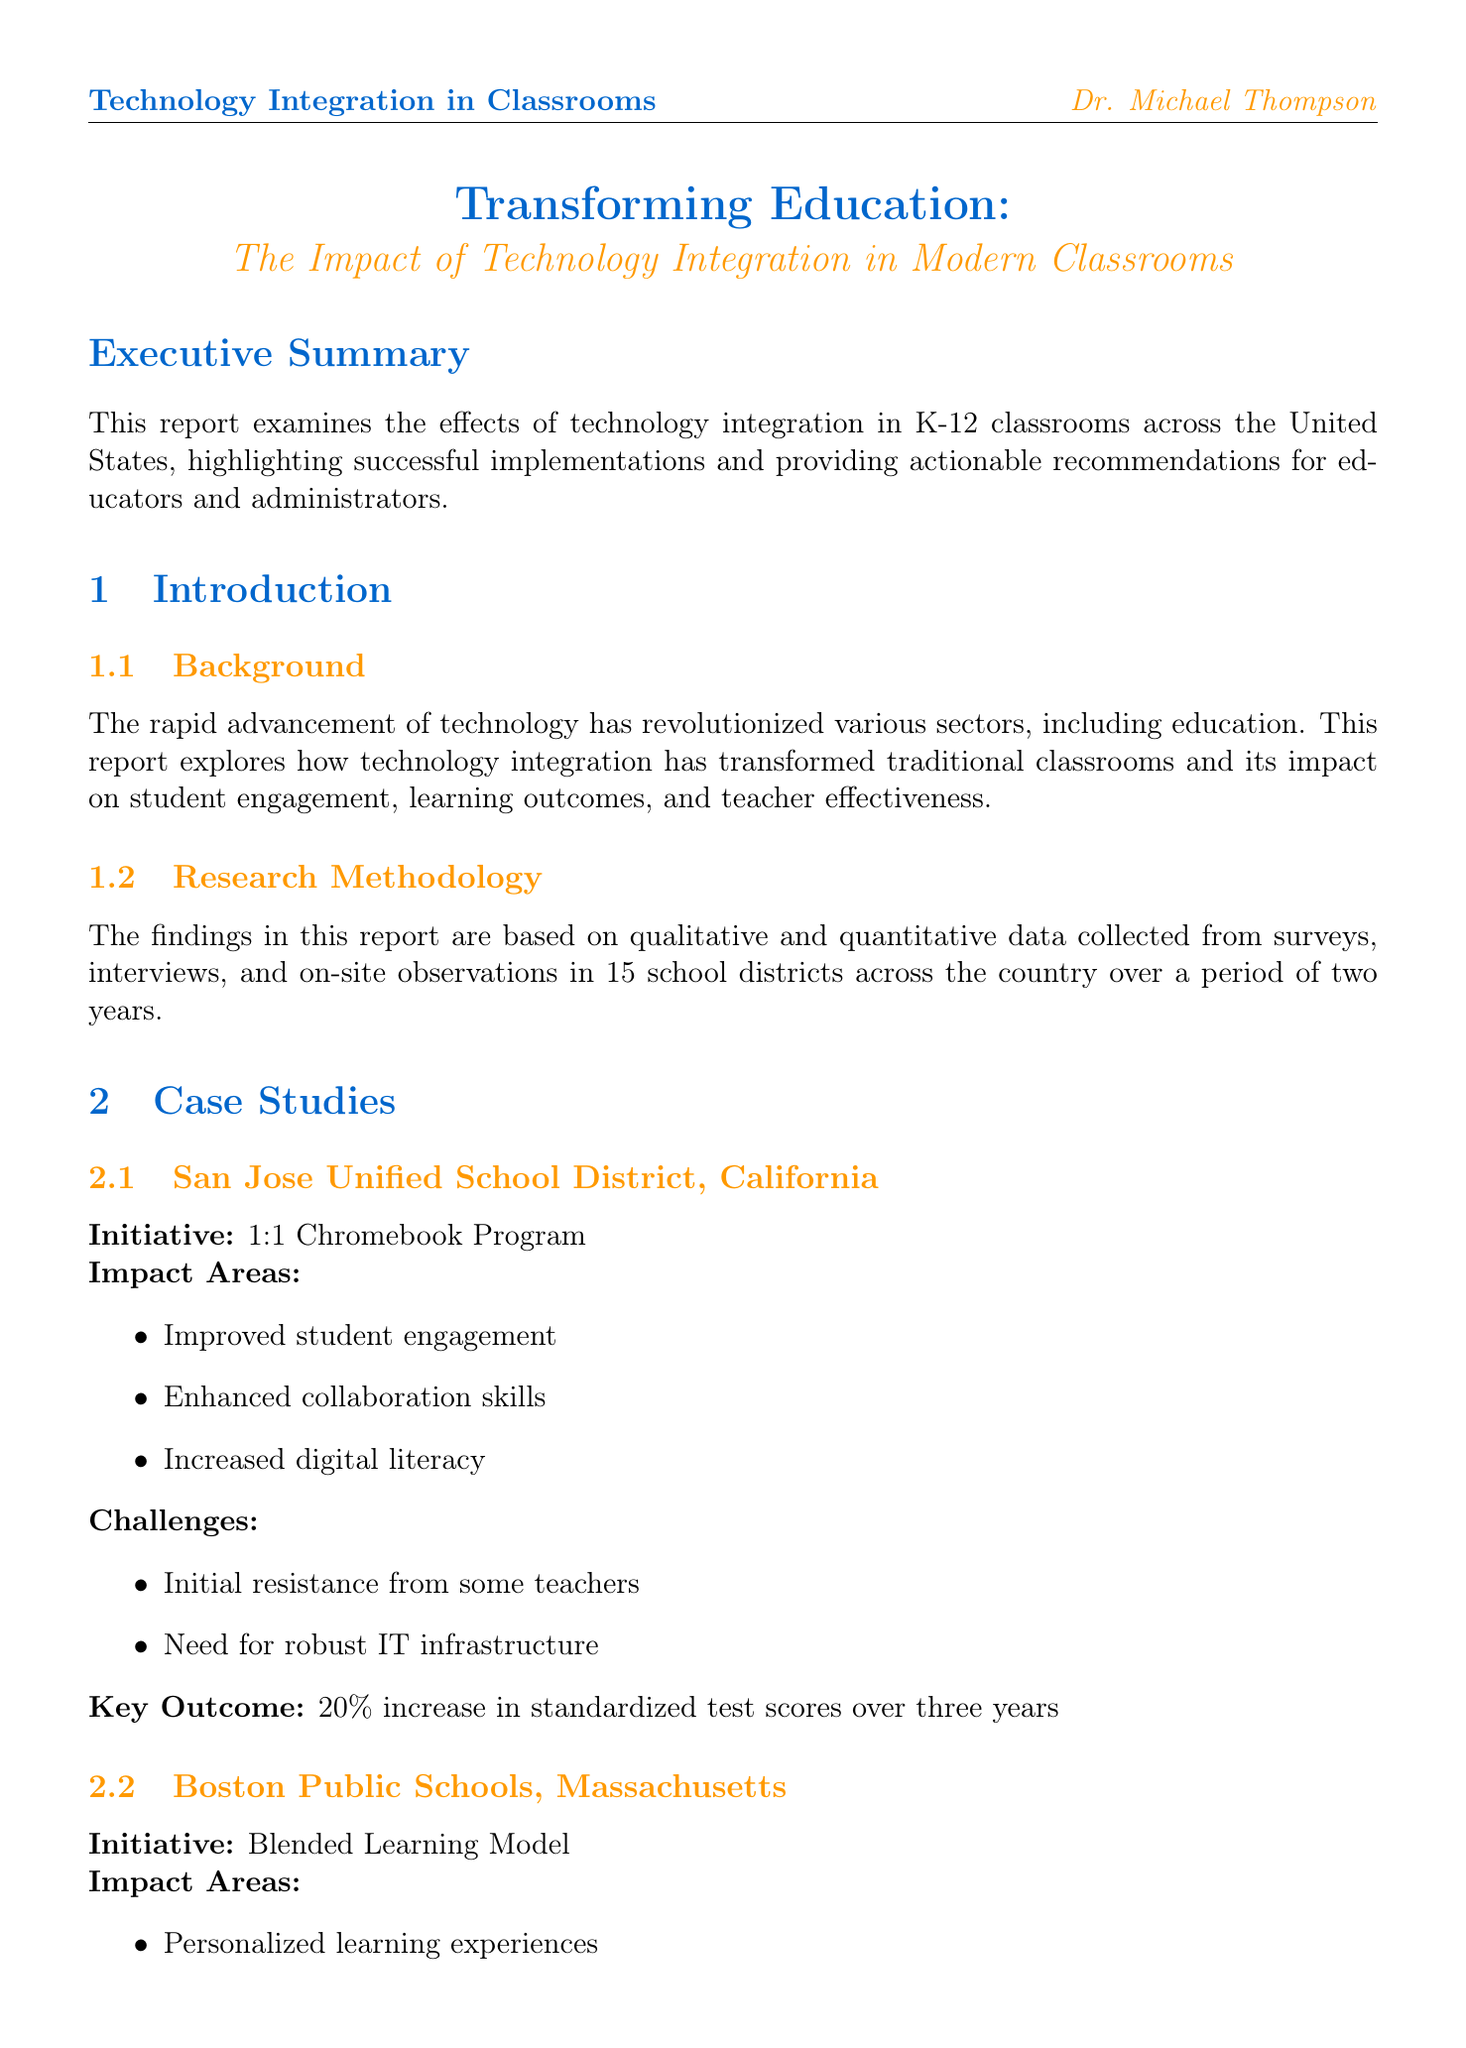What is the title of the report? The title is a specific identifier for the report provided in the document.
Answer: Transforming Education: The Impact of Technology Integration in Modern Classrooms Who is the author of the report? The author is mentioned in the "About the Author" section of the document, providing credentials and current role.
Answer: Dr. Michael Thompson Which district implemented a 1:1 Chromebook Program? This question asks for the name of the school district associated with a specific technology initiative listed in the case studies.
Answer: San Jose Unified School District What percentage of students in Miami-Dade County Public Schools pursued STEM majors after the initiative? The percentage represents the outcome of a specific technology initiative from the case study mentioned.
Answer: 30% What is one challenge faced by Boston Public Schools regarding technology integration? This question requires the identification of a challenge listed in the case study related to technology initiatives.
Answer: Ensuring equitable access to technology at home What is one recommendation for ensuring equitable access to technology? This question asks for specific steps outlined in the recommendations section for addressing equitable access.
Answer: Implement 1:1 device programs What was the key outcome of the San Jose Unified School District's technology initiative? The key outcome is a specific measurable result attributed to the technology integration in the case study.
Answer: 20% increase in standardized test scores over three years What research methodology was used for the report? This request is for the type of research approach employed to gather data for the report, as mentioned in the introduction.
Answer: Qualitative and quantitative data collection 